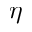<formula> <loc_0><loc_0><loc_500><loc_500>\eta</formula> 